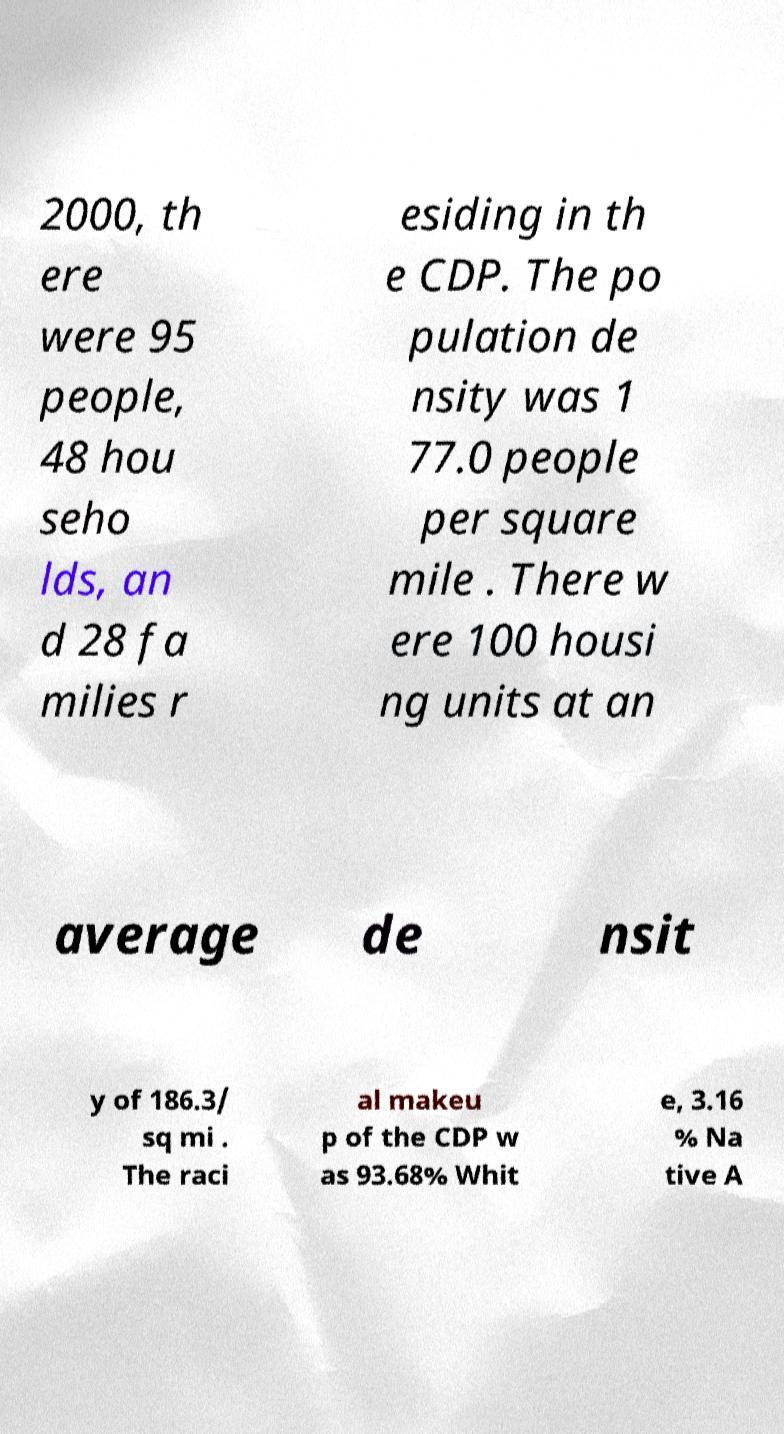Could you assist in decoding the text presented in this image and type it out clearly? 2000, th ere were 95 people, 48 hou seho lds, an d 28 fa milies r esiding in th e CDP. The po pulation de nsity was 1 77.0 people per square mile . There w ere 100 housi ng units at an average de nsit y of 186.3/ sq mi . The raci al makeu p of the CDP w as 93.68% Whit e, 3.16 % Na tive A 